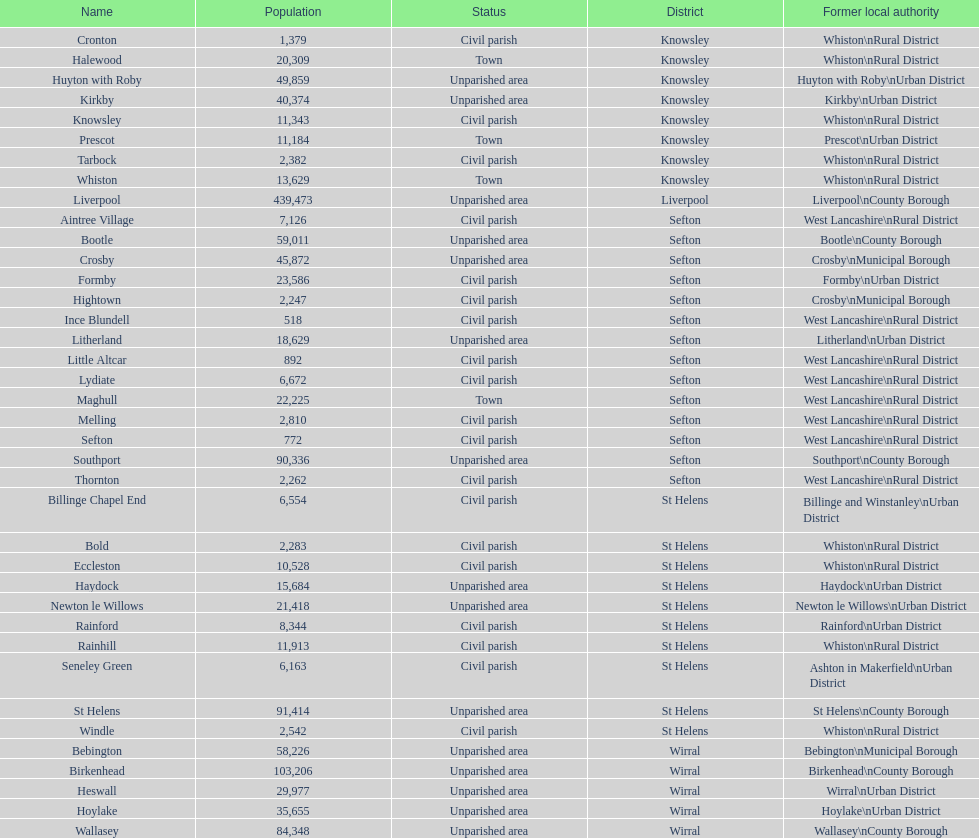Which is a civil parish, aintree village or maghull? Aintree Village. 